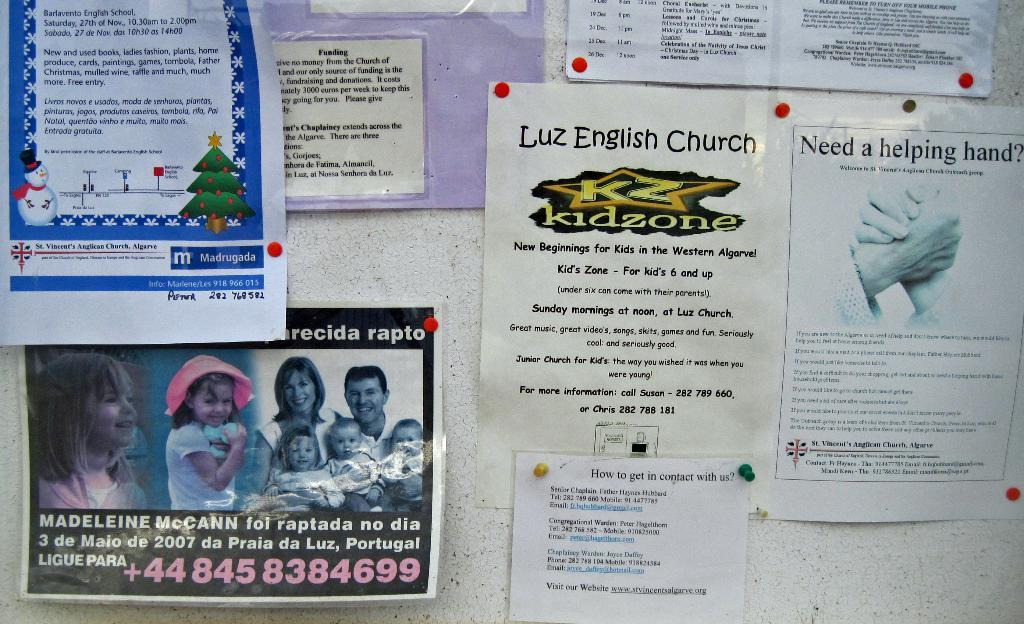Provide a one-sentence caption for the provided image. An ad for the kidzone at Luiz English Church lists information about the venue. 